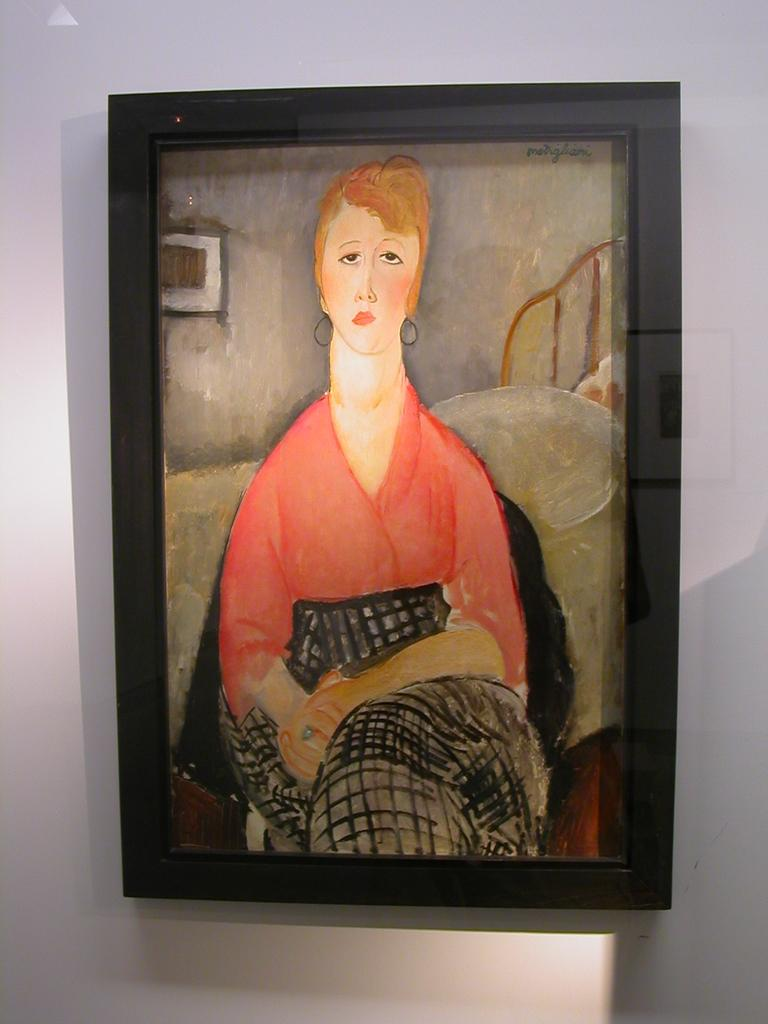What is hanging on the wall in the image? There is a photo frame on the wall. What is inside the photo frame? The photo frame contains a painting. What is the subject of the painting? The painting depicts a woman. What type of wool is used to create the woman's clothing in the painting? There is no information about the type of wool used in the painting, as the image only shows a photo frame with a painting of a woman. 